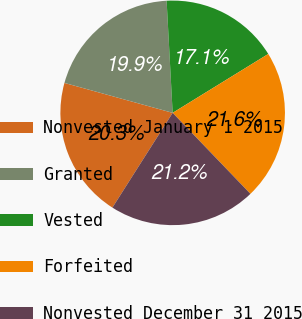<chart> <loc_0><loc_0><loc_500><loc_500><pie_chart><fcel>Nonvested January 1 2015<fcel>Granted<fcel>Vested<fcel>Forfeited<fcel>Nonvested December 31 2015<nl><fcel>20.28%<fcel>19.85%<fcel>17.07%<fcel>21.61%<fcel>21.19%<nl></chart> 